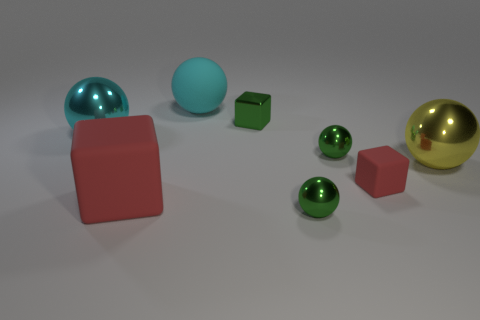Subtract all yellow blocks. How many cyan balls are left? 2 Subtract all rubber cubes. How many cubes are left? 1 Add 1 yellow cylinders. How many objects exist? 9 Subtract all green spheres. How many spheres are left? 3 Subtract all purple spheres. Subtract all yellow cylinders. How many spheres are left? 5 Subtract all spheres. How many objects are left? 3 Add 1 tiny red matte spheres. How many tiny red matte spheres exist? 1 Subtract 0 brown cubes. How many objects are left? 8 Subtract all big yellow metallic balls. Subtract all green metal balls. How many objects are left? 5 Add 2 yellow balls. How many yellow balls are left? 3 